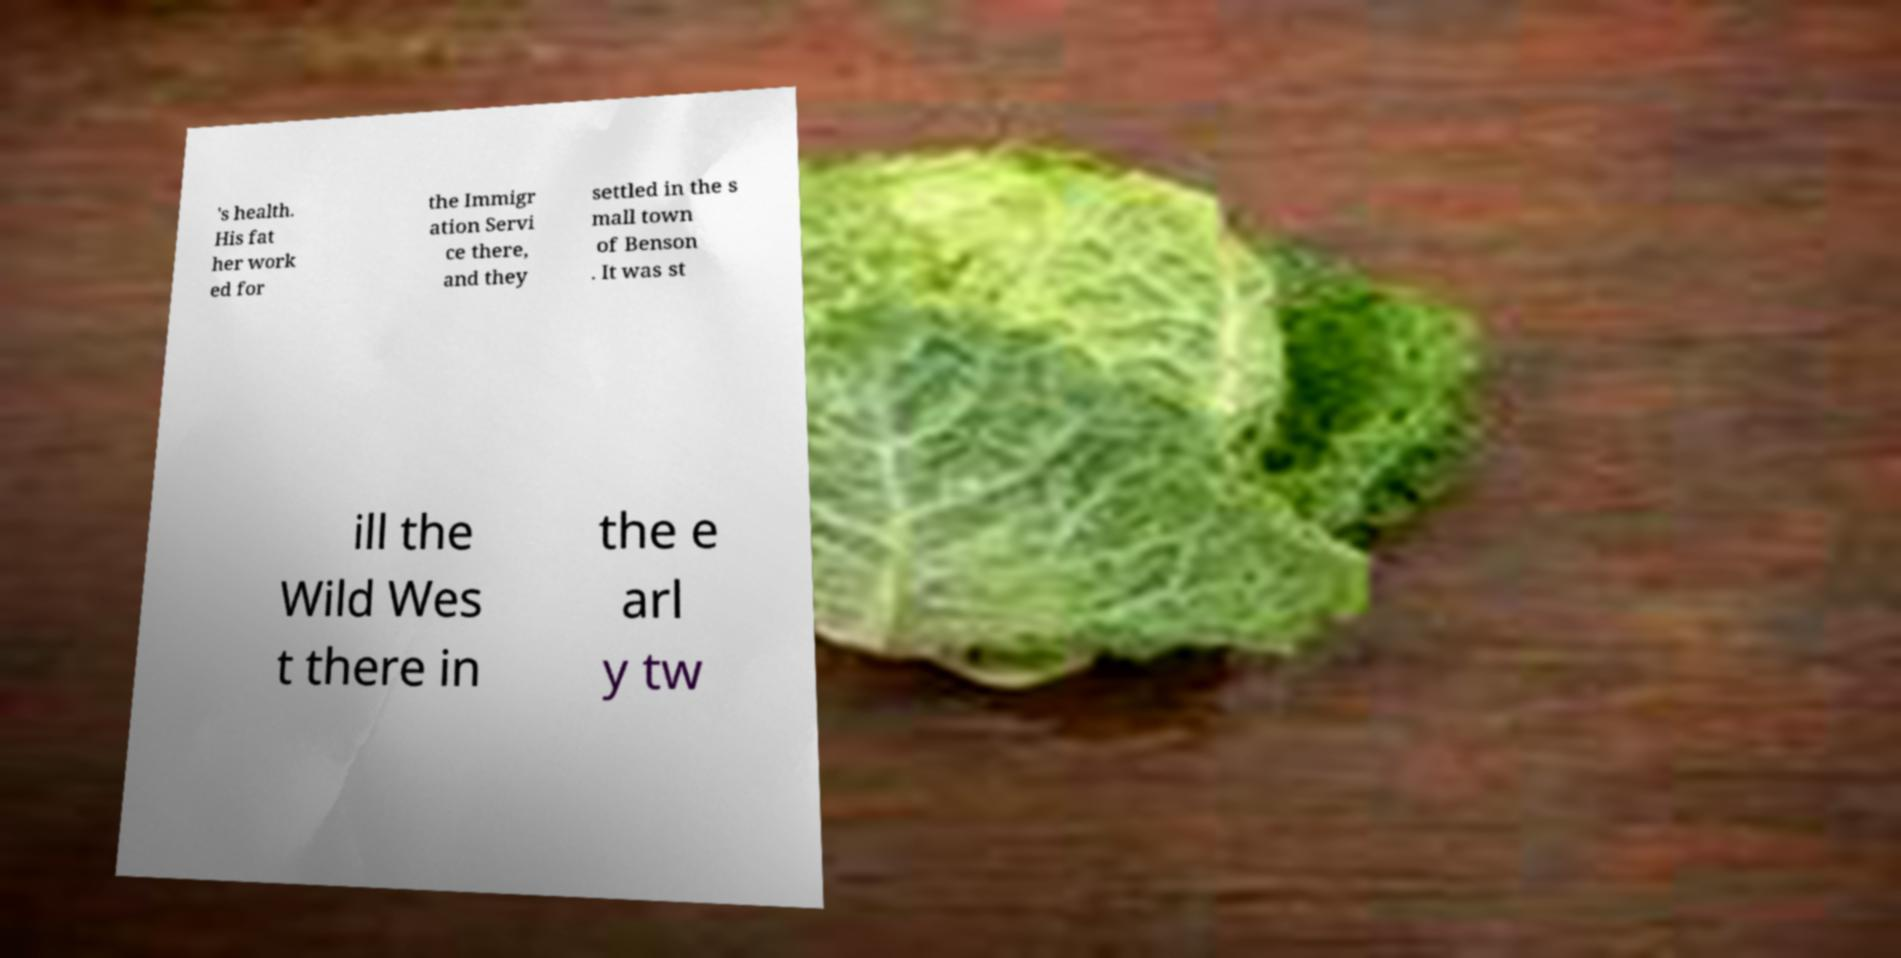Can you accurately transcribe the text from the provided image for me? 's health. His fat her work ed for the Immigr ation Servi ce there, and they settled in the s mall town of Benson . It was st ill the Wild Wes t there in the e arl y tw 